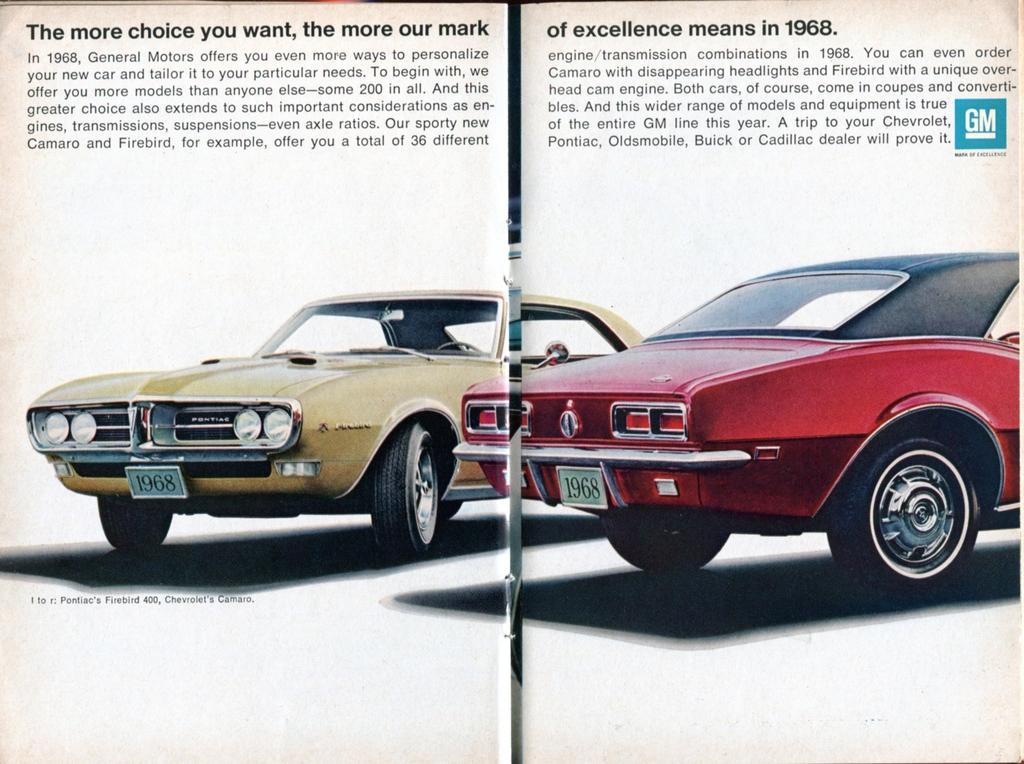What is the main subject of the image? The image appears to be an open book. What can be found inside the book? There is text in the book. Are there any illustrations or images in the book? Yes, there are images of two cars in the book. Can you tell me how deep the river is in the image? There is no river present in the image; it features an open book with text and images of two cars. How much income can be earned from the dock in the image? There is no dock present in the image; it features an open book with text and images of two cars. 